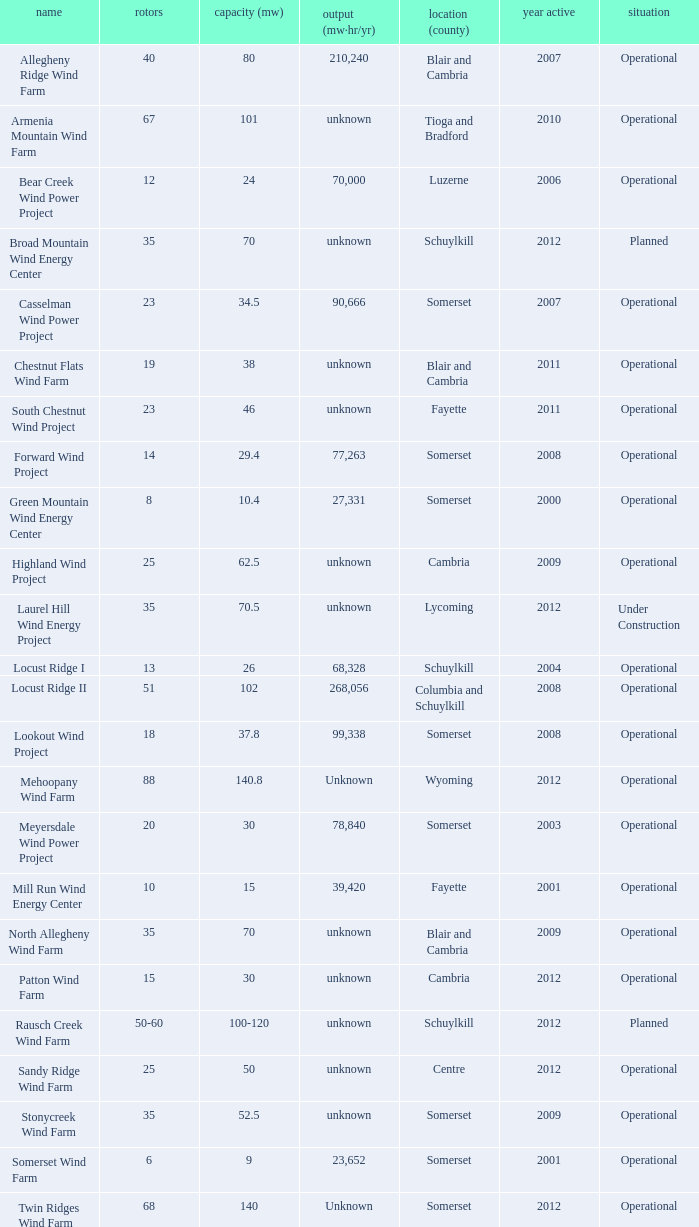What all turbines have a capacity of 30 and have a Somerset location? 20.0. 